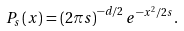<formula> <loc_0><loc_0><loc_500><loc_500>P _ { s } \left ( x \right ) = \left ( 2 \pi s \right ) ^ { - d / 2 } e ^ { - x ^ { 2 } / 2 s } .</formula> 